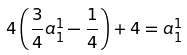<formula> <loc_0><loc_0><loc_500><loc_500>4 \left ( \frac { 3 } { 4 } a ^ { 1 } _ { 1 } - \frac { 1 } { 4 } \right ) + 4 = a ^ { 1 } _ { 1 }</formula> 